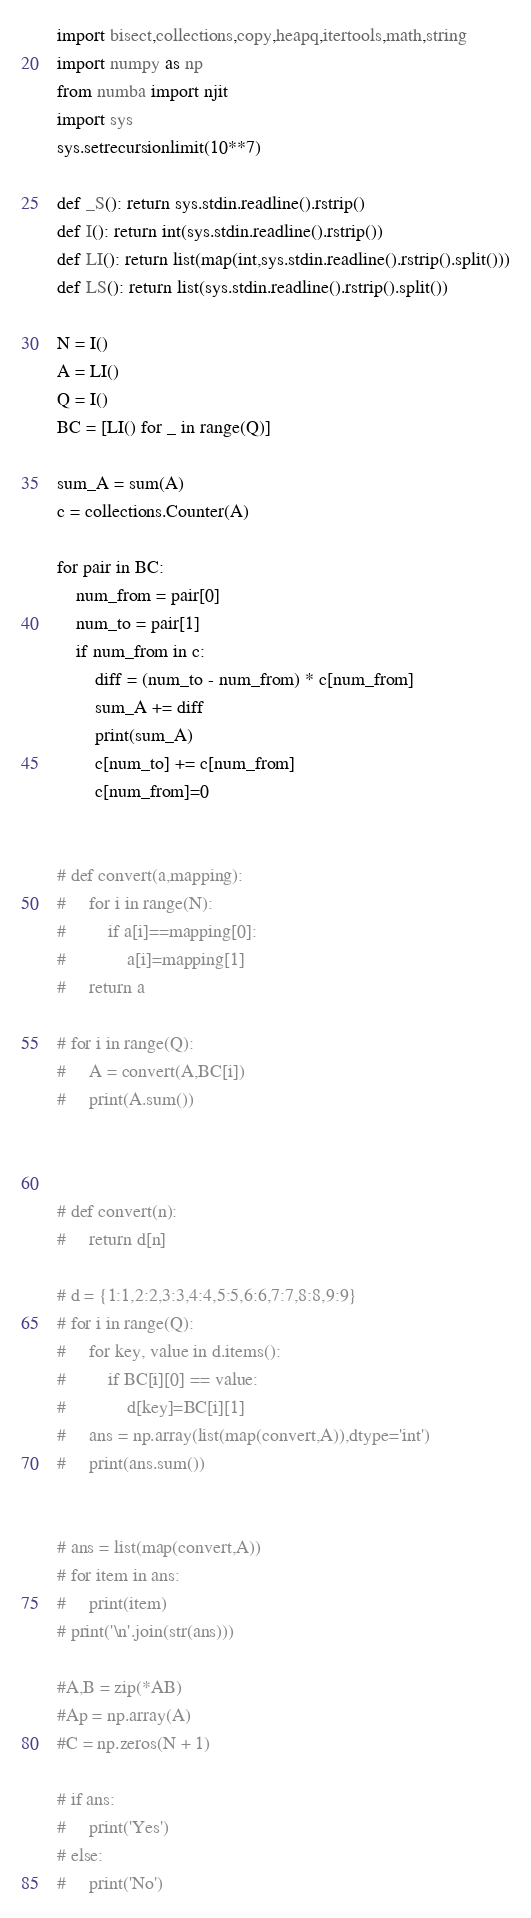<code> <loc_0><loc_0><loc_500><loc_500><_Python_>import bisect,collections,copy,heapq,itertools,math,string
import numpy as np
from numba import njit
import sys
sys.setrecursionlimit(10**7)

def _S(): return sys.stdin.readline().rstrip()
def I(): return int(sys.stdin.readline().rstrip())
def LI(): return list(map(int,sys.stdin.readline().rstrip().split()))
def LS(): return list(sys.stdin.readline().rstrip().split())

N = I()
A = LI()
Q = I()
BC = [LI() for _ in range(Q)]

sum_A = sum(A)
c = collections.Counter(A)

for pair in BC:
    num_from = pair[0]
    num_to = pair[1]
    if num_from in c:
        diff = (num_to - num_from) * c[num_from]
        sum_A += diff
        print(sum_A)
        c[num_to] += c[num_from]
        c[num_from]=0
       

# def convert(a,mapping):
#     for i in range(N):
#         if a[i]==mapping[0]:
#             a[i]=mapping[1]
#     return a

# for i in range(Q):
#     A = convert(A,BC[i])
#     print(A.sum())



# def convert(n):
#     return d[n]

# d = {1:1,2:2,3:3,4:4,5:5,6:6,7:7,8:8,9:9}
# for i in range(Q):
#     for key, value in d.items():
#         if BC[i][0] == value:
#             d[key]=BC[i][1]
#     ans = np.array(list(map(convert,A)),dtype='int')
#     print(ans.sum())


# ans = list(map(convert,A))
# for item in ans:
#     print(item)
# print('\n'.join(str(ans)))

#A,B = zip(*AB)
#Ap = np.array(A)
#C = np.zeros(N + 1)

# if ans:
#     print('Yes')
# else:
#     print('No')</code> 